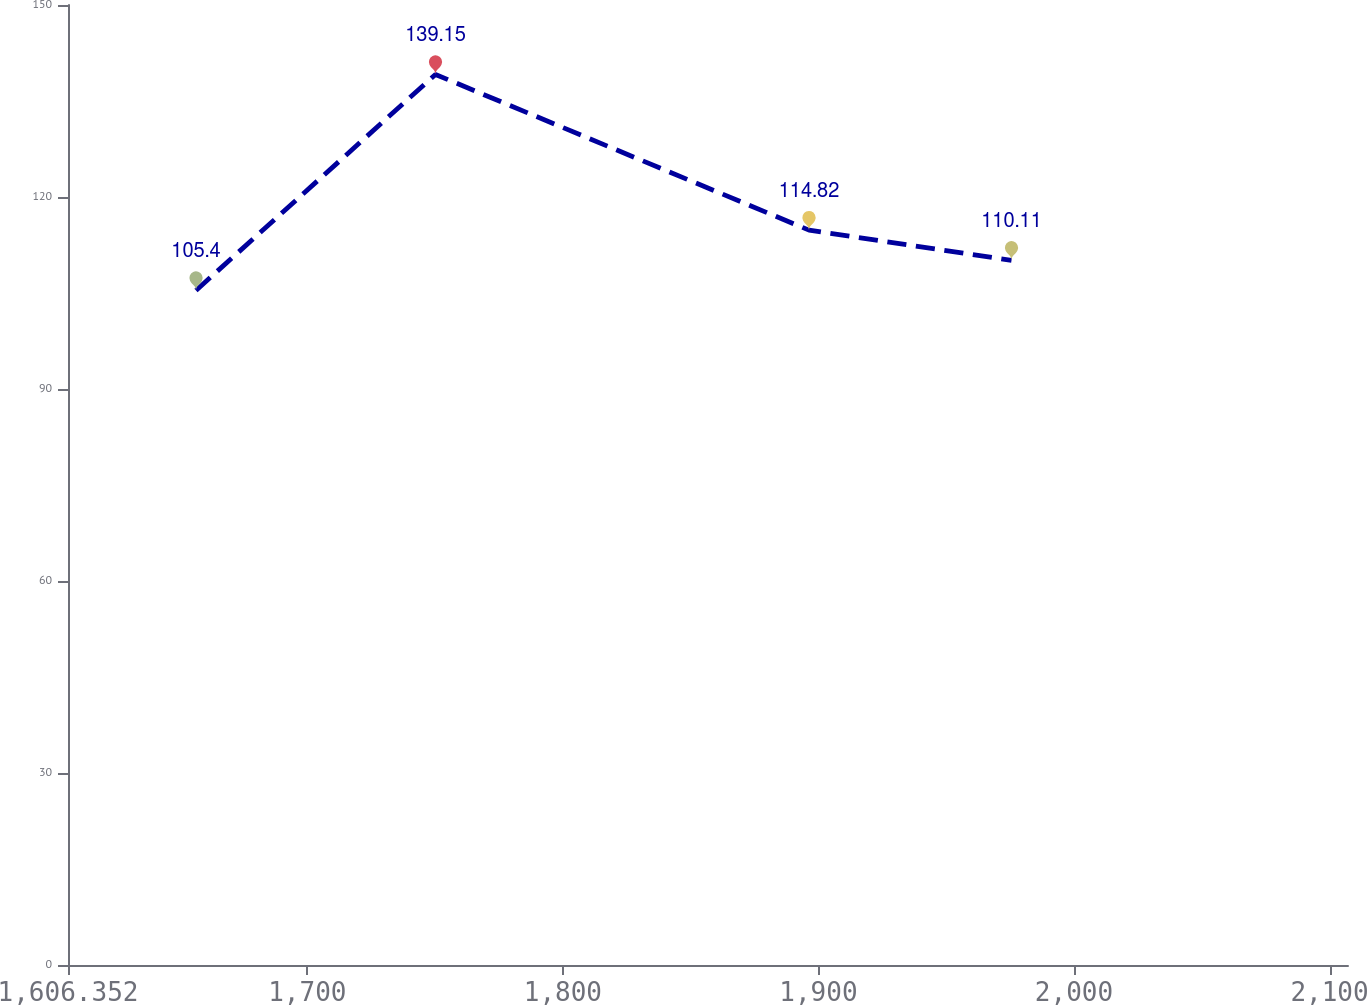Convert chart to OTSL. <chart><loc_0><loc_0><loc_500><loc_500><line_chart><ecel><fcel>Unnamed: 1<nl><fcel>1656.44<fcel>105.4<nl><fcel>1750.15<fcel>139.15<nl><fcel>1896.32<fcel>114.82<nl><fcel>1975.56<fcel>110.11<nl><fcel>2157.32<fcel>92.05<nl></chart> 